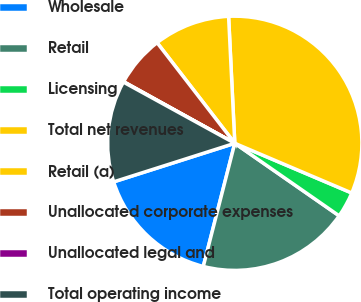<chart> <loc_0><loc_0><loc_500><loc_500><pie_chart><fcel>Wholesale<fcel>Retail<fcel>Licensing<fcel>Total net revenues<fcel>Retail (a)<fcel>Unallocated corporate expenses<fcel>Unallocated legal and<fcel>Total operating income<nl><fcel>16.11%<fcel>19.32%<fcel>3.27%<fcel>32.17%<fcel>9.69%<fcel>6.48%<fcel>0.06%<fcel>12.9%<nl></chart> 